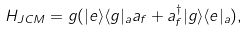Convert formula to latex. <formula><loc_0><loc_0><loc_500><loc_500>H _ { J C M } = g ( | e \rangle \langle g | _ { a } a _ { f } + a ^ { \dagger } _ { f } | g \rangle \langle e | _ { a } ) ,</formula> 